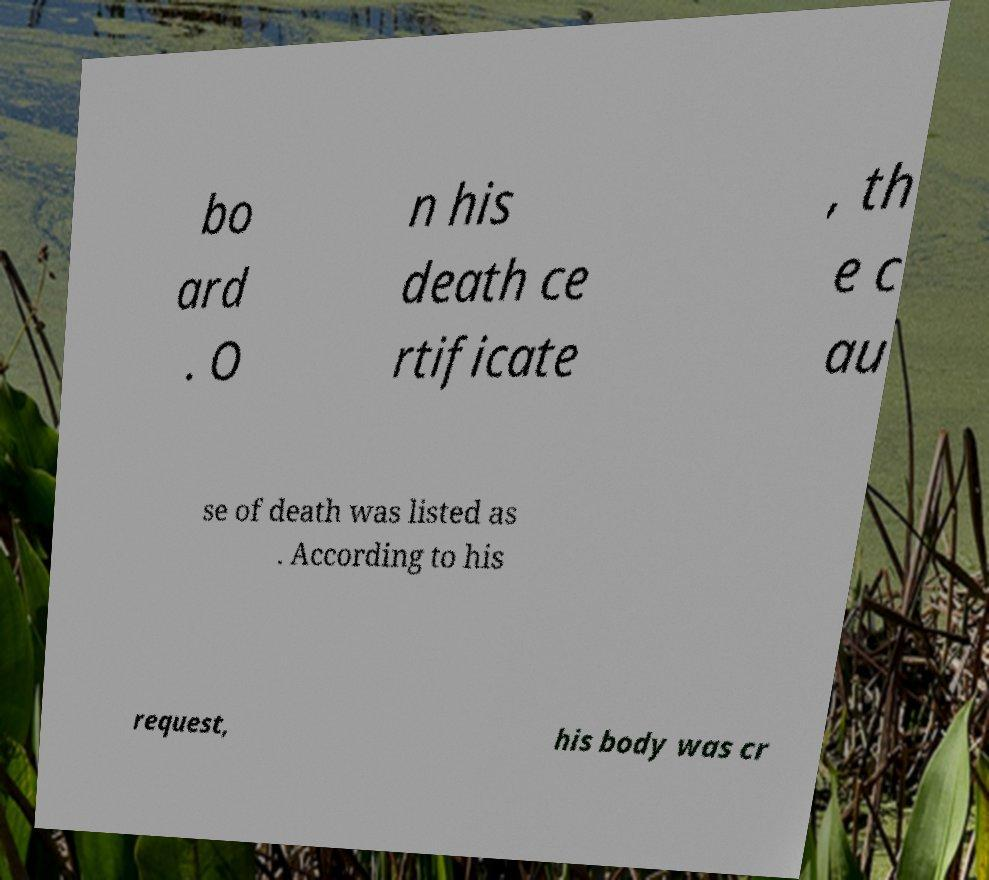Can you read and provide the text displayed in the image?This photo seems to have some interesting text. Can you extract and type it out for me? bo ard . O n his death ce rtificate , th e c au se of death was listed as . According to his request, his body was cr 